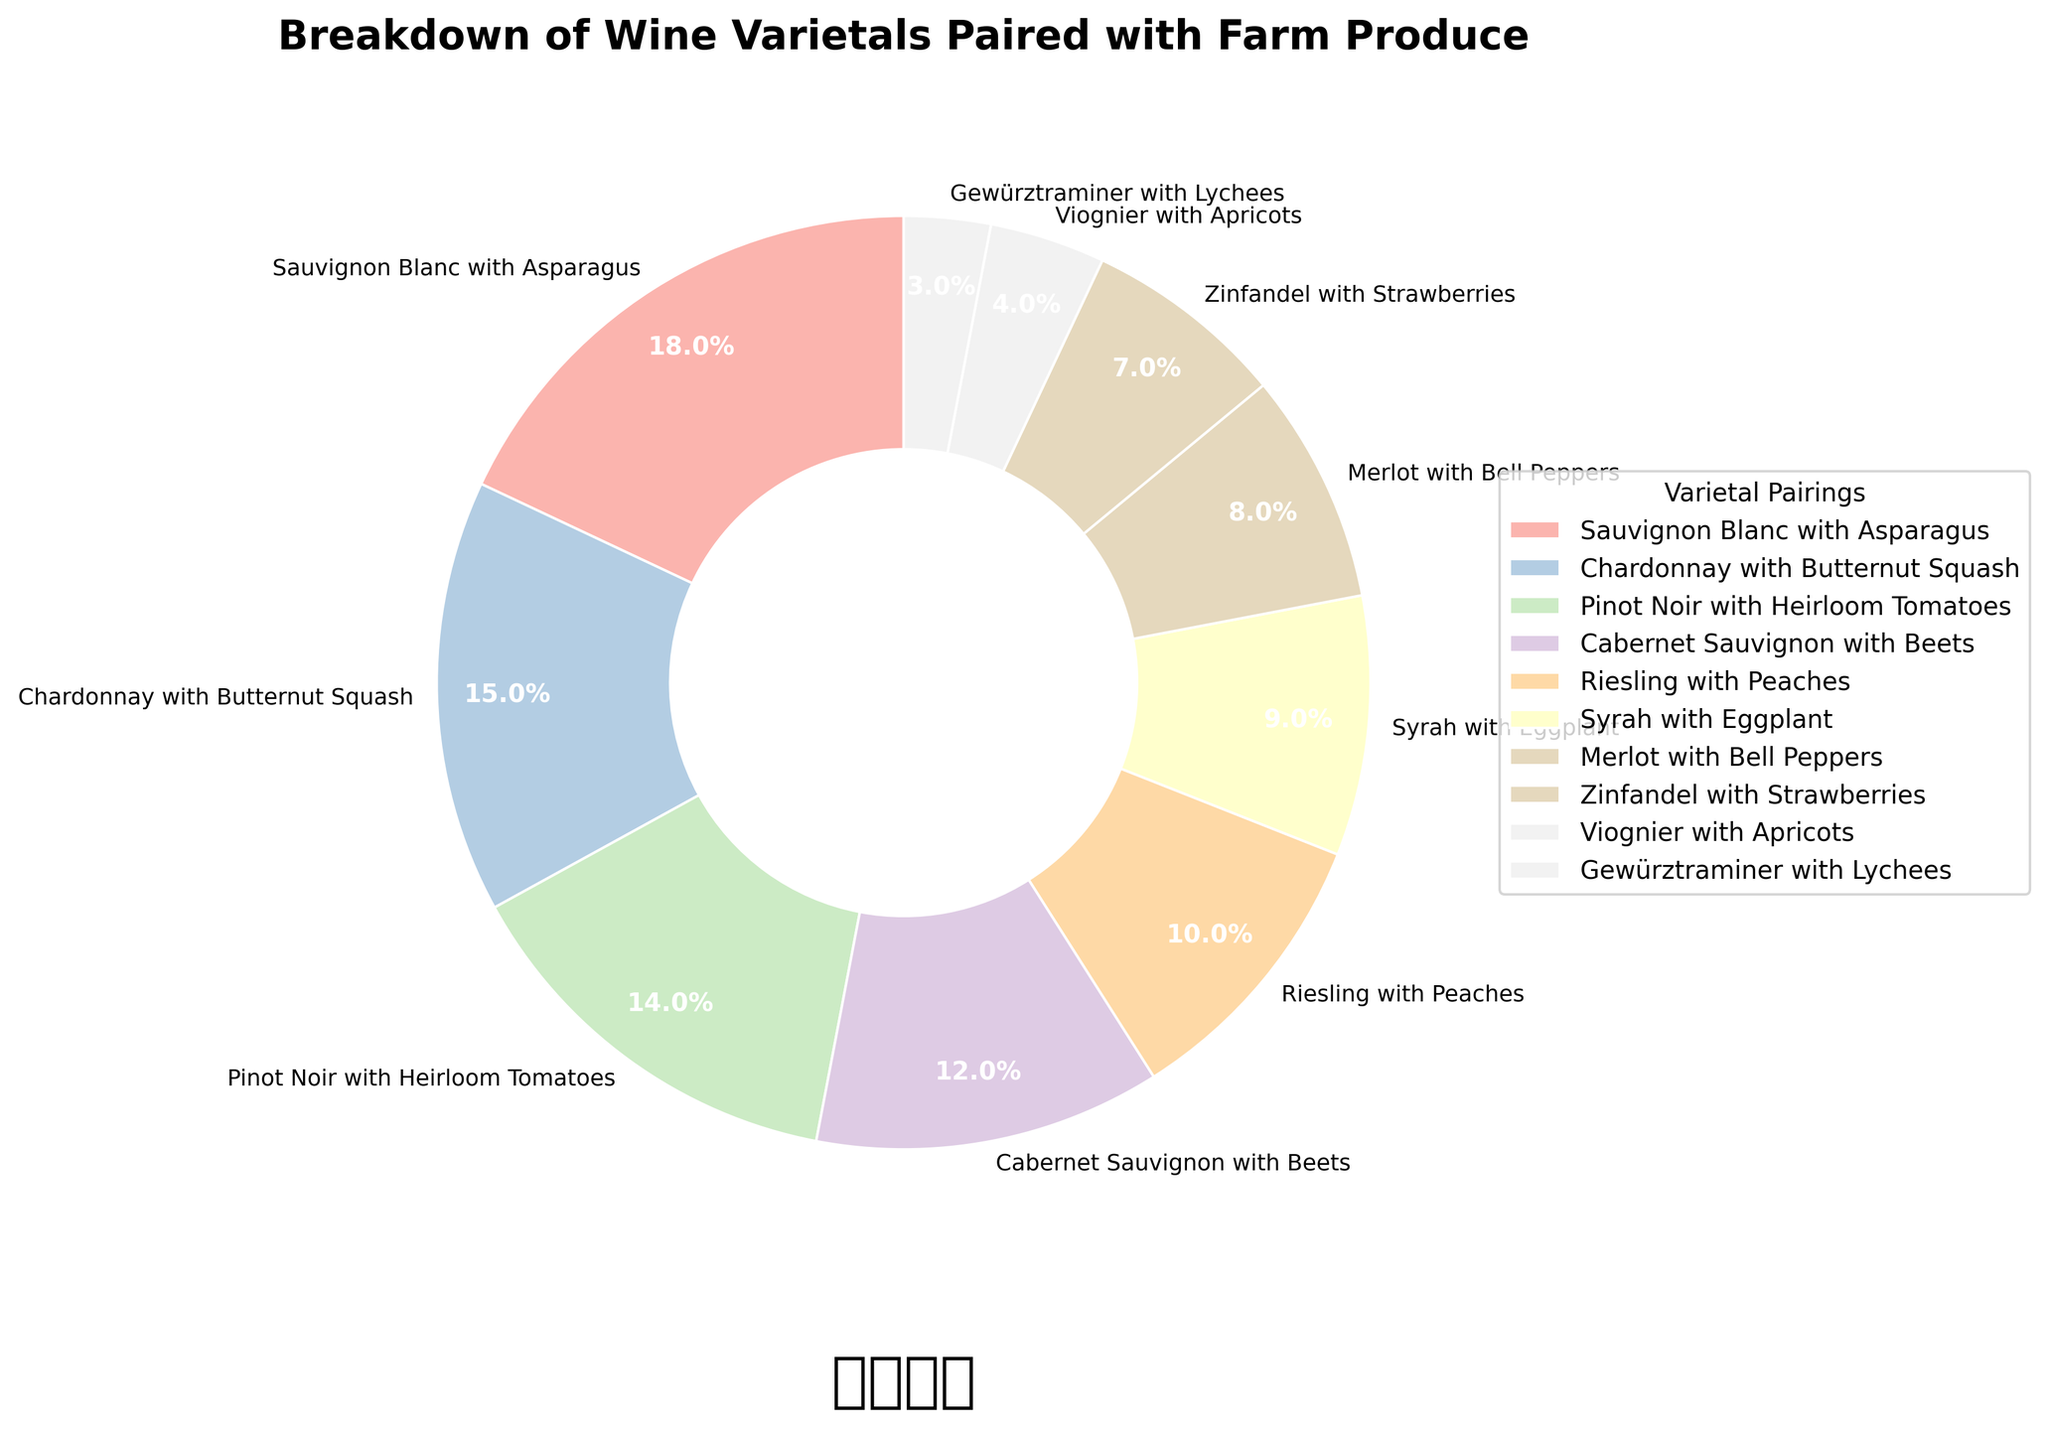What wine varietal pairing has the highest percentage? Refer to the pie chart and look for the segment with the largest value. The segment labeled "Sauvignon Blanc with Asparagus" is the largest at 18%.
Answer: Sauvignon Blanc with Asparagus What is the sum of percentages for Chardonnay with Butternut Squash and Pinot Noir with Heirloom Tomatoes? Add the percentages of these two segments: 15% (Chardonnay with Butternut Squash) + 14% (Pinot Noir with Heirloom Tomatoes) = 29%.
Answer: 29% Which wine varietal pairing has a higher percentage, Syrah with Eggplant or Merlot with Bell Peppers? Compare the two segments "Syrah with Eggplant" (9%) and "Merlot with Bell Peppers" (8%). Syrah with Eggplant has a higher percentage.
Answer: Syrah with Eggplant What is the percentage difference between Cabernet Sauvignon with Beets and Zinfandel with Strawberries? Subtract the percentage of Zinfandel with Strawberries from Cabernet Sauvignon with Beets: 12% (Cabernet Sauvignon with Beets) - 7% (Zinfandel with Strawberries) = 5%.
Answer: 5% Which varietal pairing occupies a smaller segment, Viognier with Apricots or Gewürztraminer with Lychees? Compare the two segments: Viognier with Apricots at 4% and Gewürztraminer with Lychees at 3%. Gewürztraminer with Lychees is smaller.
Answer: Gewürztraminer with Lychees What is the combined percentage of the three smallest varietal pairings? Add the percentages of Gewürztraminer with Lychees (3%), Viognier with Apricots (4%), and Zinfandel with Strawberries (7%): 3% + 4% + 7% = 14%.
Answer: 14% Which color is associated with Riesling with Peaches? Look at the pie chart and identify the color for the segment labeled "Riesling with Peaches." It uses one of the colors from the Pastel1 colormap, but specific visible interpretation is needed from the chart.
Answer: Pastel color (details visible on the chart) How much larger is the percentage of Sauvignon Blanc with Asparagus compared to Merlot with Bell Peppers? Subtract the percentage of Merlot with Bell Peppers from Sauvignon Blanc with Asparagus: 18% - 8% = 10%.
Answer: 10% What is the average percentage of all the varietal pairings in the chart? Sum all percentages and then divide by the number of pairings. Sum: 18% + 15% + 14% + 12% + 10% + 9% + 8% + 7% + 4% + 3% = 100%. Average is 100% / 10 = 10%.
Answer: 10% What are the varietal pairings that make up more than 10% each? Identify the segments with percentages greater than 10%. They are: Sauvignon Blanc with Asparagus (18%), Chardonnay with Butternut Squash (15%), and Pinot Noir with Heirloom Tomatoes (14%).
Answer: Sauvignon Blanc with Asparagus, Chardonnay with Butternut Squash, Pinot Noir with Heirloom Tomatoes 